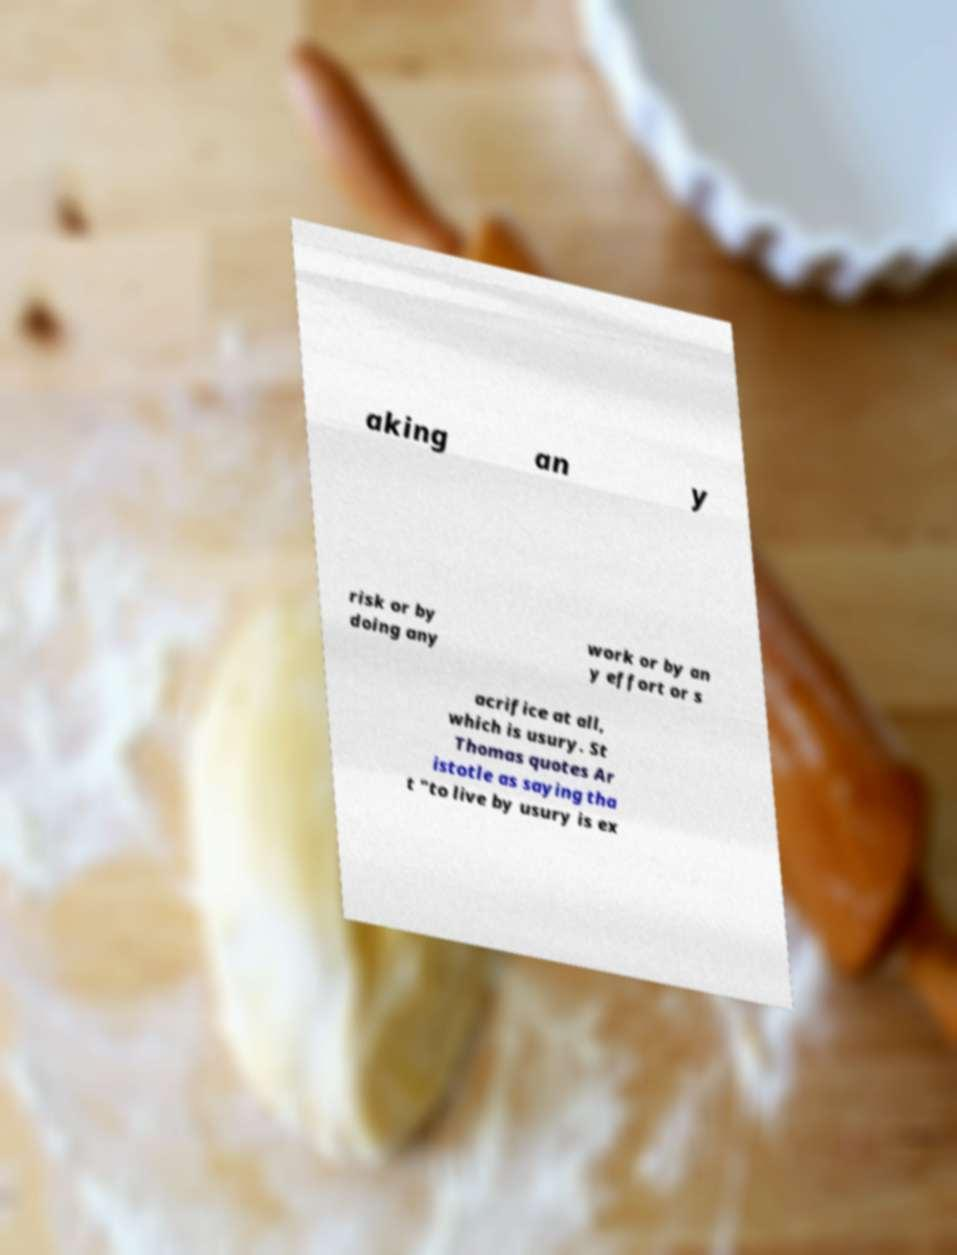Could you assist in decoding the text presented in this image and type it out clearly? aking an y risk or by doing any work or by an y effort or s acrifice at all, which is usury. St Thomas quotes Ar istotle as saying tha t "to live by usury is ex 